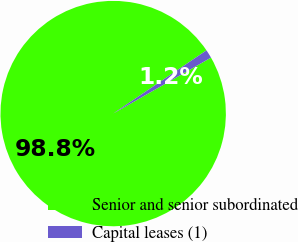Convert chart. <chart><loc_0><loc_0><loc_500><loc_500><pie_chart><fcel>Senior and senior subordinated<fcel>Capital leases (1)<nl><fcel>98.79%<fcel>1.21%<nl></chart> 